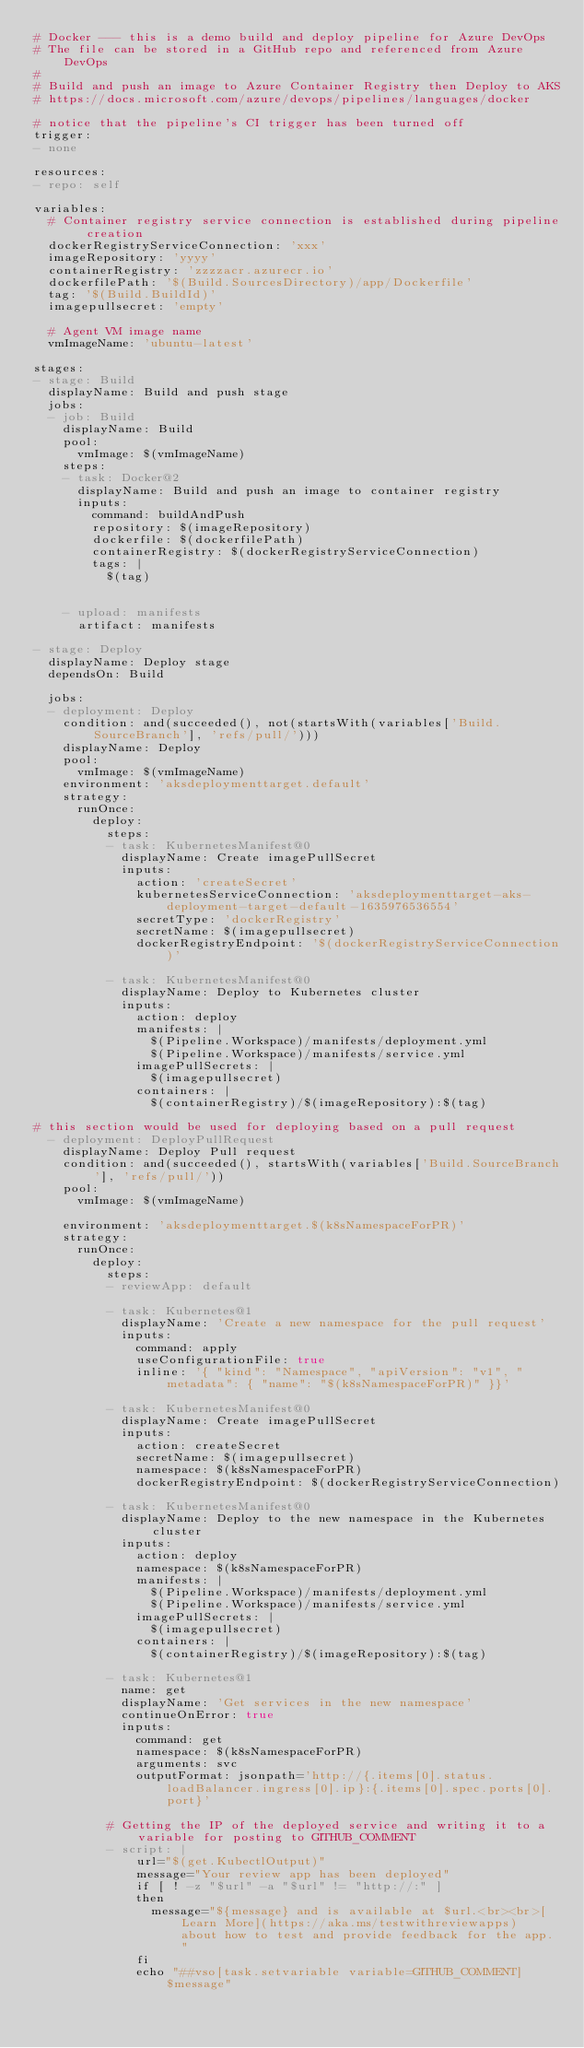<code> <loc_0><loc_0><loc_500><loc_500><_YAML_># Docker --- this is a demo build and deploy pipeline for Azure DevOps
# The file can be stored in a GitHub repo and referenced from Azure DevOps
# 
# Build and push an image to Azure Container Registry then Deploy to AKS
# https://docs.microsoft.com/azure/devops/pipelines/languages/docker

# notice that the pipeline's CI trigger has been turned off
trigger:
- none

resources:
- repo: self

variables:
  # Container registry service connection is established during pipeline creation
  dockerRegistryServiceConnection: 'xxx'
  imageRepository: 'yyyy'
  containerRegistry: 'zzzzacr.azurecr.io'
  dockerfilePath: '$(Build.SourcesDirectory)/app/Dockerfile'
  tag: '$(Build.BuildId)'
  imagepullsecret: 'empty'

  # Agent VM image name
  vmImageName: 'ubuntu-latest'

stages:
- stage: Build
  displayName: Build and push stage
  jobs:
  - job: Build
    displayName: Build
    pool:
      vmImage: $(vmImageName)
    steps:
    - task: Docker@2
      displayName: Build and push an image to container registry
      inputs:
        command: buildAndPush
        repository: $(imageRepository)
        dockerfile: $(dockerfilePath)
        containerRegistry: $(dockerRegistryServiceConnection)
        tags: |
          $(tag)


    - upload: manifests
      artifact: manifests

- stage: Deploy
  displayName: Deploy stage
  dependsOn: Build

  jobs:
  - deployment: Deploy
    condition: and(succeeded(), not(startsWith(variables['Build.SourceBranch'], 'refs/pull/')))
    displayName: Deploy
    pool:
      vmImage: $(vmImageName)
    environment: 'aksdeploymenttarget.default'
    strategy:
      runOnce:
        deploy:
          steps:
          - task: KubernetesManifest@0
            displayName: Create imagePullSecret
            inputs:
              action: 'createSecret'
              kubernetesServiceConnection: 'aksdeploymenttarget-aks-deployment-target-default-1635976536554'
              secretType: 'dockerRegistry'
              secretName: $(imagepullsecret)
              dockerRegistryEndpoint: '$(dockerRegistryServiceConnection)'

          - task: KubernetesManifest@0
            displayName: Deploy to Kubernetes cluster
            inputs:
              action: deploy
              manifests: |
                $(Pipeline.Workspace)/manifests/deployment.yml
                $(Pipeline.Workspace)/manifests/service.yml
              imagePullSecrets: |
                $(imagepullsecret)
              containers: |
                $(containerRegistry)/$(imageRepository):$(tag)

# this section would be used for deploying based on a pull request 
  - deployment: DeployPullRequest
    displayName: Deploy Pull request
    condition: and(succeeded(), startsWith(variables['Build.SourceBranch'], 'refs/pull/'))
    pool:
      vmImage: $(vmImageName)

    environment: 'aksdeploymenttarget.$(k8sNamespaceForPR)'
    strategy:
      runOnce:
        deploy:
          steps:
          - reviewApp: default

          - task: Kubernetes@1
            displayName: 'Create a new namespace for the pull request'
            inputs:
              command: apply
              useConfigurationFile: true
              inline: '{ "kind": "Namespace", "apiVersion": "v1", "metadata": { "name": "$(k8sNamespaceForPR)" }}'

          - task: KubernetesManifest@0
            displayName: Create imagePullSecret
            inputs:
              action: createSecret
              secretName: $(imagepullsecret)
              namespace: $(k8sNamespaceForPR)
              dockerRegistryEndpoint: $(dockerRegistryServiceConnection)

          - task: KubernetesManifest@0
            displayName: Deploy to the new namespace in the Kubernetes cluster
            inputs:
              action: deploy
              namespace: $(k8sNamespaceForPR)
              manifests: |
                $(Pipeline.Workspace)/manifests/deployment.yml
                $(Pipeline.Workspace)/manifests/service.yml
              imagePullSecrets: |
                $(imagepullsecret)
              containers: |
                $(containerRegistry)/$(imageRepository):$(tag)

          - task: Kubernetes@1
            name: get
            displayName: 'Get services in the new namespace'
            continueOnError: true
            inputs:
              command: get
              namespace: $(k8sNamespaceForPR)
              arguments: svc
              outputFormat: jsonpath='http://{.items[0].status.loadBalancer.ingress[0].ip}:{.items[0].spec.ports[0].port}'

          # Getting the IP of the deployed service and writing it to a variable for posting to GITHUB_COMMENT
          - script: |
              url="$(get.KubectlOutput)"
              message="Your review app has been deployed"
              if [ ! -z "$url" -a "$url" != "http://:" ]
              then
                message="${message} and is available at $url.<br><br>[Learn More](https://aka.ms/testwithreviewapps) about how to test and provide feedback for the app."
              fi
              echo "##vso[task.setvariable variable=GITHUB_COMMENT]$message"
</code> 